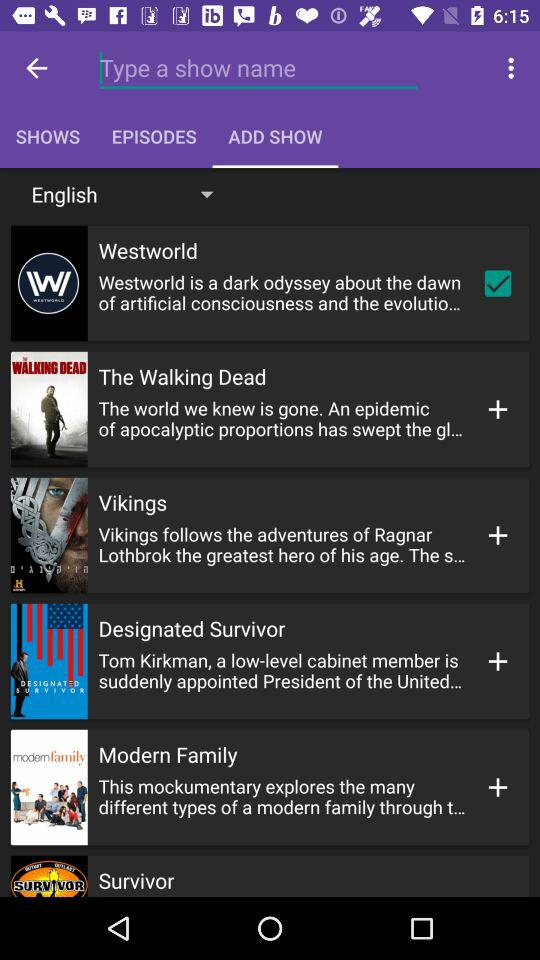Which tab is selected? The selected tab is "Add Show". 